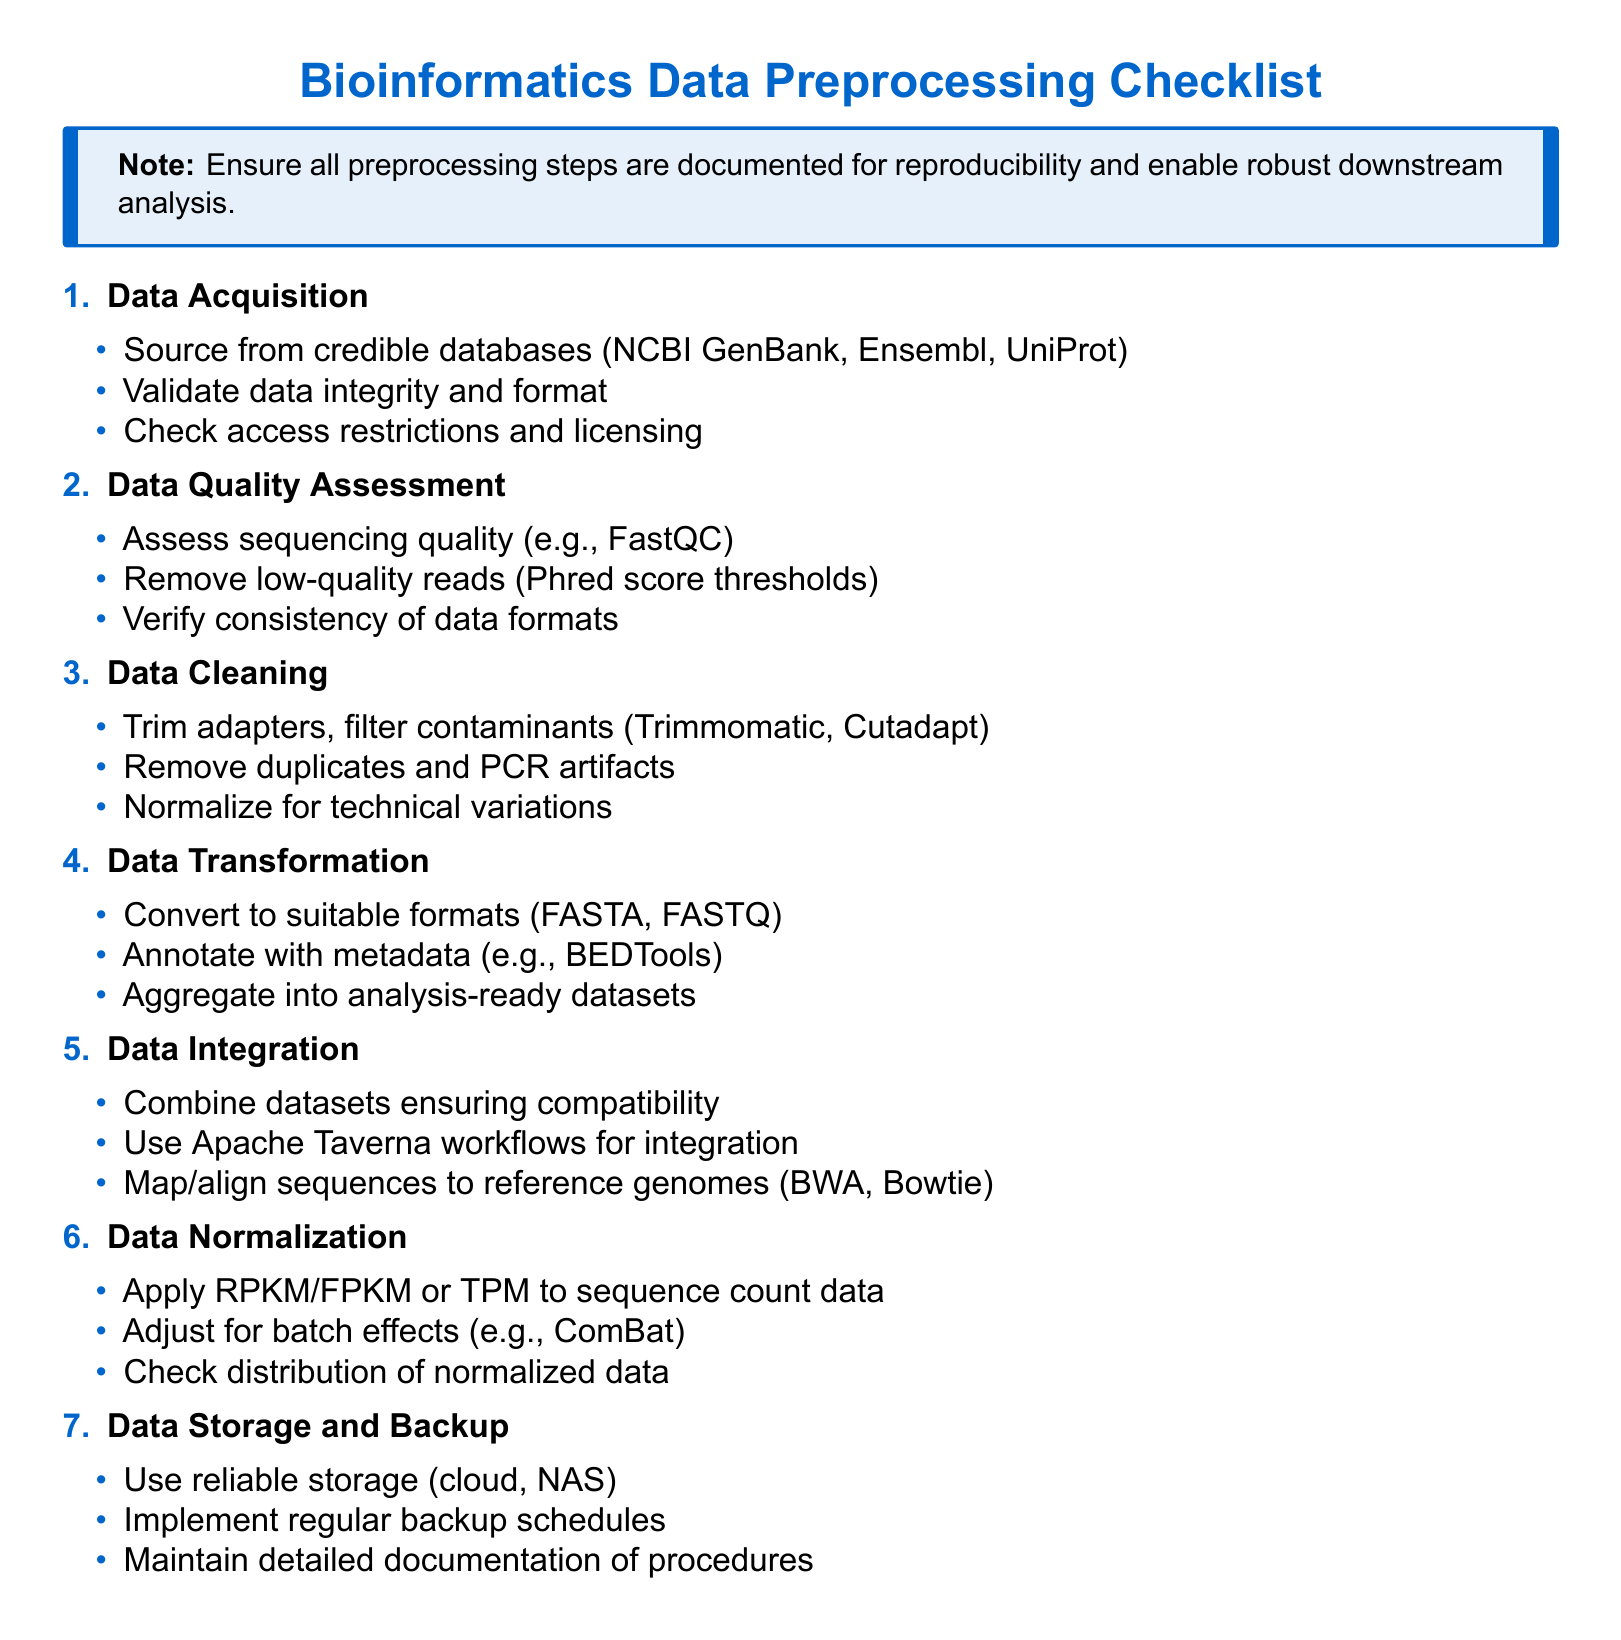What is the first step in the bioinformatics data preprocessing checklist? The first step is to acquire the data from credible sources, which includes assessing the integrity and format.
Answer: Data Acquisition Which tool is mentioned for assessing sequencing quality? FastQC is specifically mentioned as a tool for assessing sequencing quality in the checklist.
Answer: FastQC What type of data transformation is suggested in the checklist? The checklist suggests converting data to suitable formats like FASTA or FASTQ as part of data transformation.
Answer: Suitable formats What should be checked for during data normalization? The distribution of normalized data should be checked to ensure consistency and reliability.
Answer: Distribution Which software is recommended for data integration workflows? Apache Taverna is recommended for creating workflows that integrate bioinformatics data.
Answer: Apache Taverna How often should backup schedules be implemented? The checklist emphasizes the importance of implementing regular backup schedules, though it does not specify a frequency.
Answer: Regularly What type of data should be removed during the data cleaning step? The checklist indicates that duplicates and PCR artifacts should be removed as part of the data cleaning process.
Answer: Duplicates How many main preprocessing steps are outlined in the document? The checklist outlines six main preprocessing steps for bioinformatics data processing.
Answer: Six What is the purpose of maintaining detailed documentation of procedures? Maintaining detailed documentation is essential for reproducibility in bioinformatics analyses according to the checklist.
Answer: Reproducibility 